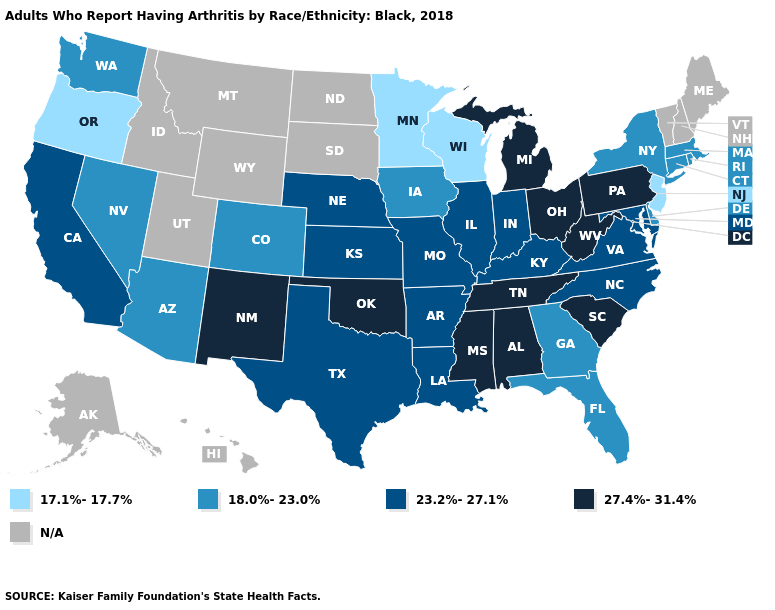What is the lowest value in states that border Michigan?
Concise answer only. 17.1%-17.7%. What is the highest value in the Northeast ?
Be succinct. 27.4%-31.4%. Does Oklahoma have the highest value in the USA?
Write a very short answer. Yes. How many symbols are there in the legend?
Write a very short answer. 5. What is the highest value in the MidWest ?
Write a very short answer. 27.4%-31.4%. What is the value of Tennessee?
Keep it brief. 27.4%-31.4%. Name the states that have a value in the range 27.4%-31.4%?
Answer briefly. Alabama, Michigan, Mississippi, New Mexico, Ohio, Oklahoma, Pennsylvania, South Carolina, Tennessee, West Virginia. Name the states that have a value in the range 17.1%-17.7%?
Write a very short answer. Minnesota, New Jersey, Oregon, Wisconsin. Name the states that have a value in the range 18.0%-23.0%?
Answer briefly. Arizona, Colorado, Connecticut, Delaware, Florida, Georgia, Iowa, Massachusetts, Nevada, New York, Rhode Island, Washington. What is the highest value in the USA?
Concise answer only. 27.4%-31.4%. What is the value of Connecticut?
Write a very short answer. 18.0%-23.0%. Does Virginia have the highest value in the USA?
Give a very brief answer. No. Name the states that have a value in the range N/A?
Be succinct. Alaska, Hawaii, Idaho, Maine, Montana, New Hampshire, North Dakota, South Dakota, Utah, Vermont, Wyoming. Name the states that have a value in the range 23.2%-27.1%?
Answer briefly. Arkansas, California, Illinois, Indiana, Kansas, Kentucky, Louisiana, Maryland, Missouri, Nebraska, North Carolina, Texas, Virginia. What is the value of Minnesota?
Be succinct. 17.1%-17.7%. 